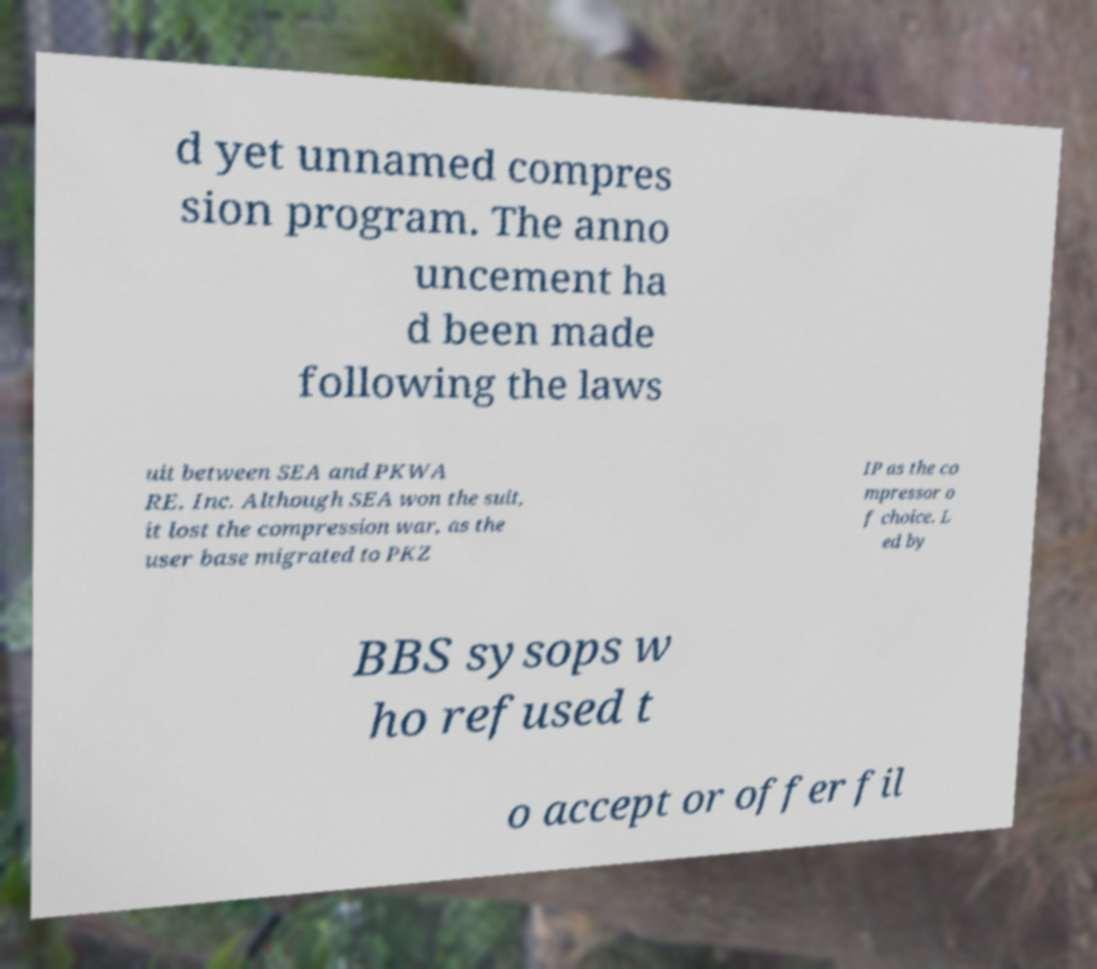For documentation purposes, I need the text within this image transcribed. Could you provide that? d yet unnamed compres sion program. The anno uncement ha d been made following the laws uit between SEA and PKWA RE, Inc. Although SEA won the suit, it lost the compression war, as the user base migrated to PKZ IP as the co mpressor o f choice. L ed by BBS sysops w ho refused t o accept or offer fil 